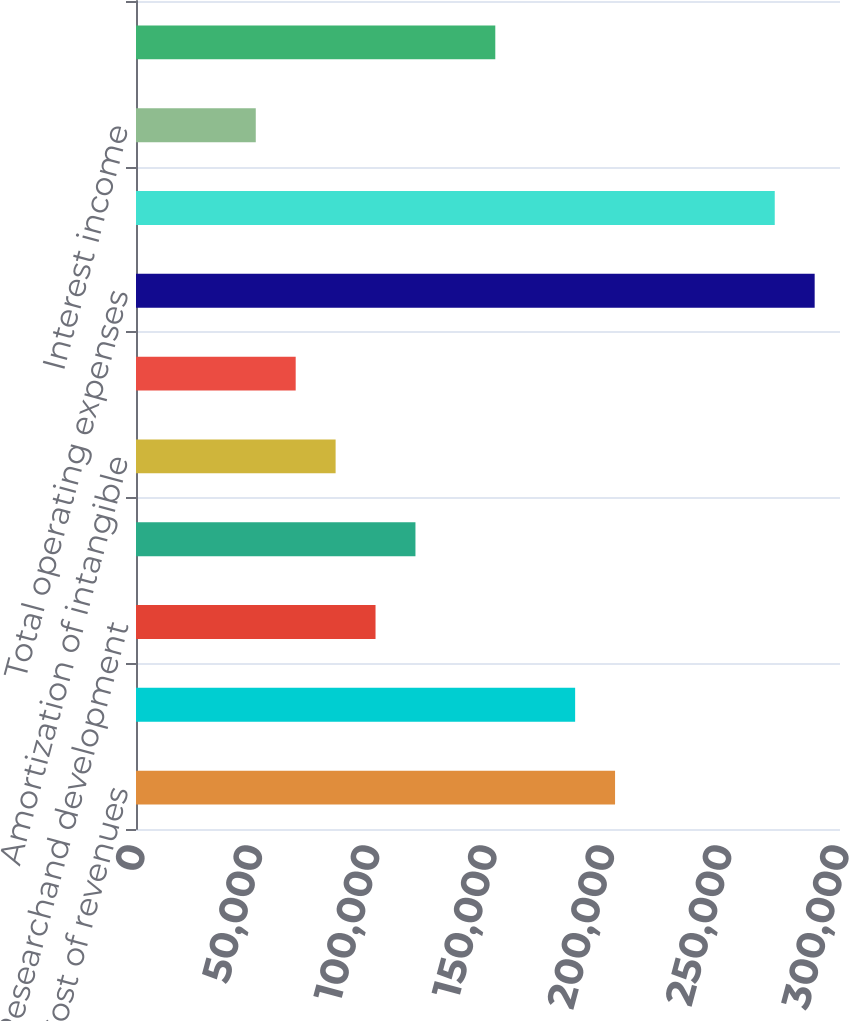Convert chart. <chart><loc_0><loc_0><loc_500><loc_500><bar_chart><fcel>Cost of revenues<fcel>Selling and marketing<fcel>Researchand development<fcel>General and administrative<fcel>Amortization of intangible<fcel>Depreciation and amortization<fcel>Total operating expenses<fcel>Operating income<fcel>Interest income<fcel>Interest expense<nl><fcel>204145<fcel>187133<fcel>102073<fcel>119085<fcel>85060.9<fcel>68048.9<fcel>289205<fcel>272193<fcel>51036.9<fcel>153109<nl></chart> 